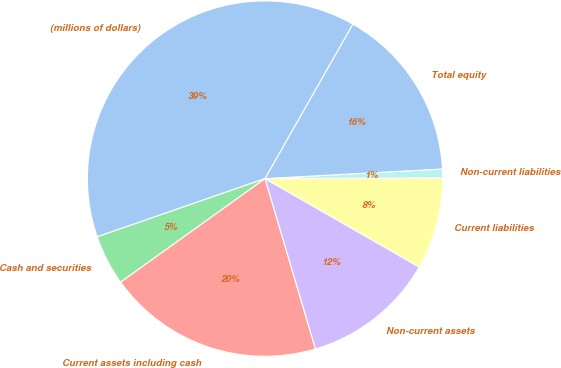Convert chart. <chart><loc_0><loc_0><loc_500><loc_500><pie_chart><fcel>(millions of dollars)<fcel>Cash and securities<fcel>Current assets including cash<fcel>Non-current assets<fcel>Current liabilities<fcel>Non-current liabilities<fcel>Total equity<nl><fcel>38.55%<fcel>4.58%<fcel>19.68%<fcel>12.13%<fcel>8.35%<fcel>0.8%<fcel>15.9%<nl></chart> 